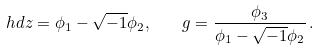<formula> <loc_0><loc_0><loc_500><loc_500>h d z = \phi _ { 1 } - \sqrt { - 1 } \phi _ { 2 } , \quad g = \frac { \phi _ { 3 } } { \phi _ { 1 } - \sqrt { - 1 } \phi _ { 2 } } \, .</formula> 